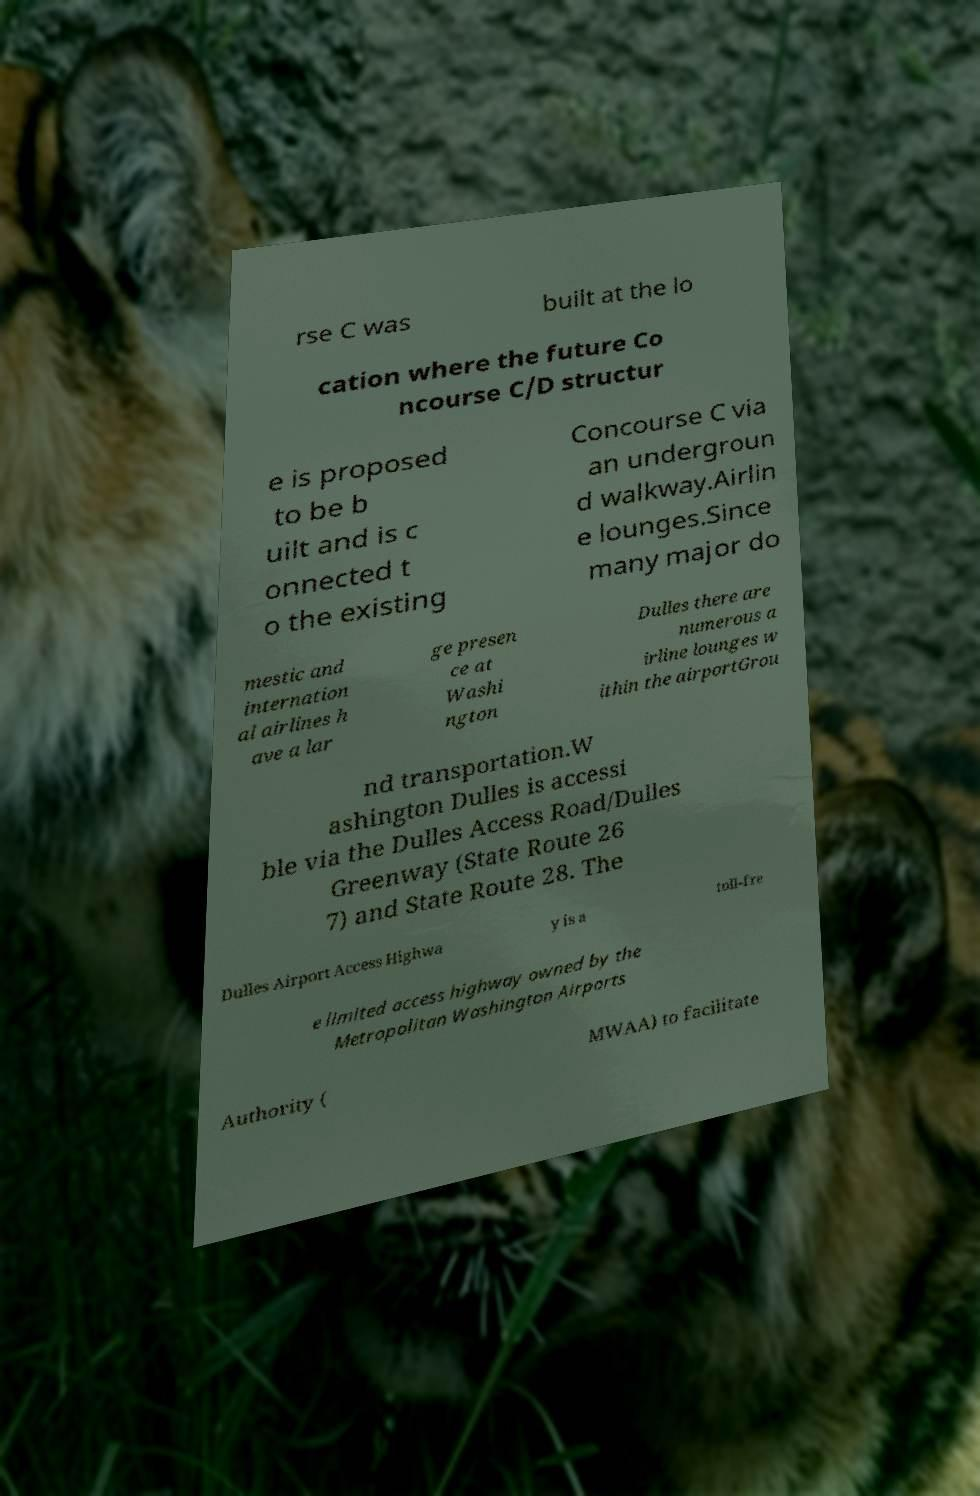Could you assist in decoding the text presented in this image and type it out clearly? rse C was built at the lo cation where the future Co ncourse C/D structur e is proposed to be b uilt and is c onnected t o the existing Concourse C via an undergroun d walkway.Airlin e lounges.Since many major do mestic and internation al airlines h ave a lar ge presen ce at Washi ngton Dulles there are numerous a irline lounges w ithin the airportGrou nd transportation.W ashington Dulles is accessi ble via the Dulles Access Road/Dulles Greenway (State Route 26 7) and State Route 28. The Dulles Airport Access Highwa y is a toll-fre e limited access highway owned by the Metropolitan Washington Airports Authority ( MWAA) to facilitate 